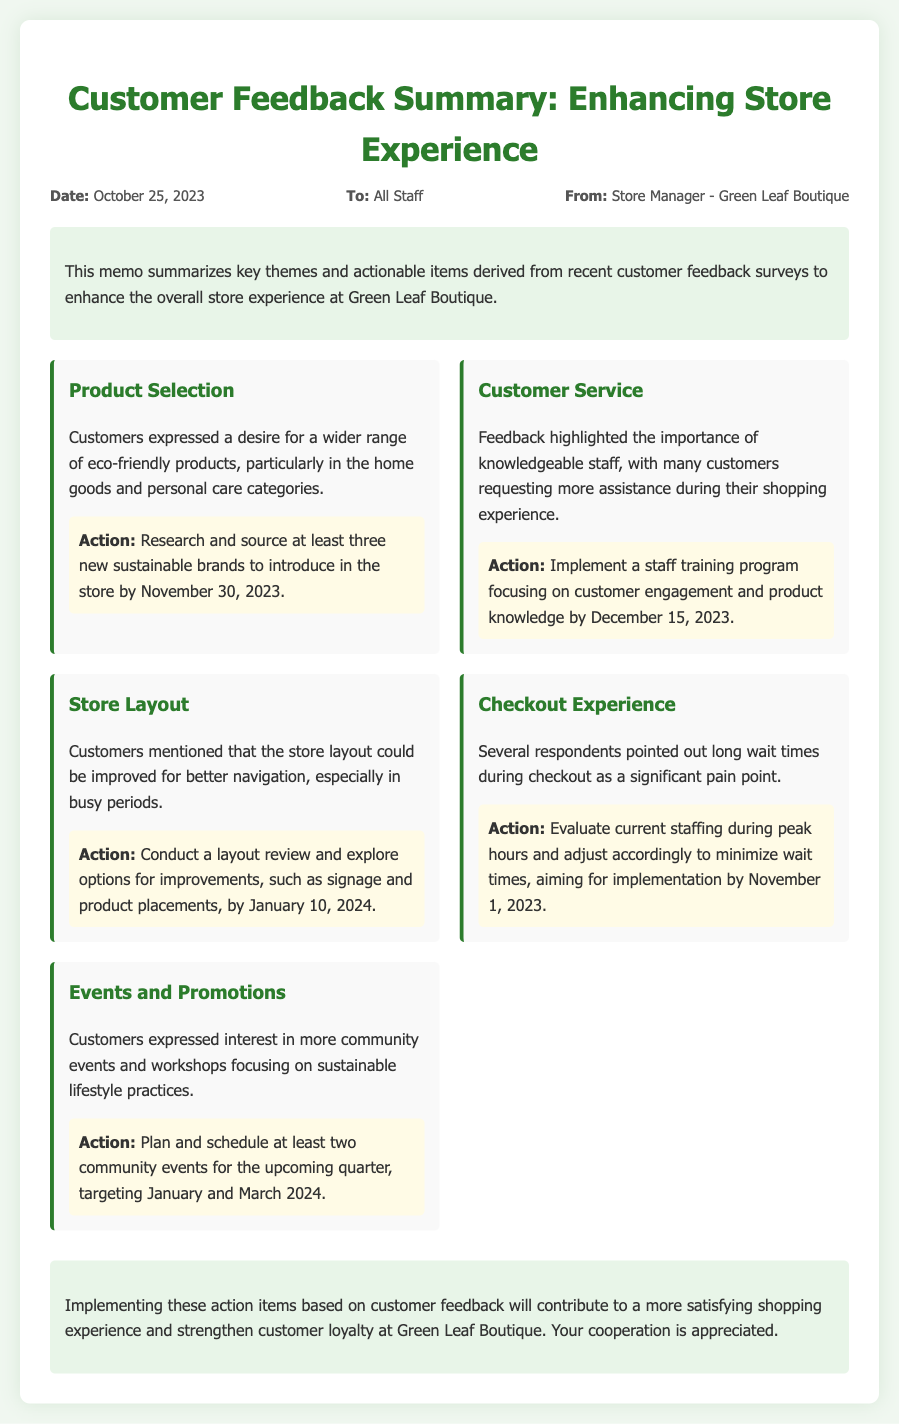what is the date of the memo? The date mentioned in the memo is October 25, 2023.
Answer: October 25, 2023 who is the sender of the memo? The sender of the memo is identified as the Store Manager of Green Leaf Boutique.
Answer: Store Manager - Green Leaf Boutique what is one key theme highlighted in the customer feedback? The document lists several key themes from the customer feedback, one of which is Product Selection.
Answer: Product Selection what is the action item associated with the checkout experience theme? The action item for the checkout experience is to evaluate current staffing during peak hours.
Answer: Evaluate current staffing during peak hours when is the deadline for researching new sustainable brands? The action item specifies that the research should be completed by November 30, 2023.
Answer: November 30, 2023 how many community events does the memo suggest planning? The memo suggests planning at least two community events for the upcoming quarter.
Answer: Two what is the main purpose of this memo? The main purpose of the memo is to summarize customer feedback and outline actionable items to enhance the store experience.
Answer: Enhance the store experience what theme requires staff training according to customer feedback? The customer feedback indicates that the Customer Service theme requires more knowledgeable staff through training.
Answer: Customer Service what is the layout review deadline mentioned in the document? The memo specifies that the layout review should be completed by January 10, 2024.
Answer: January 10, 2024 